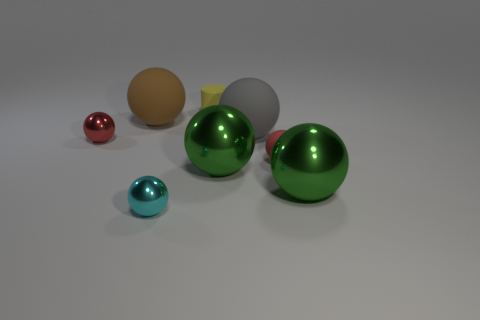Is the number of shiny objects right of the cyan metal object greater than the number of tiny brown metal cylinders?
Give a very brief answer. Yes. There is a big metal ball that is left of the tiny sphere on the right side of the cyan shiny object; what number of rubber objects are on the right side of it?
Keep it short and to the point. 2. Is the shape of the red thing to the right of the big brown ball the same as  the yellow matte thing?
Your answer should be very brief. No. What material is the tiny object that is on the left side of the small cyan ball?
Your answer should be compact. Metal. There is a big object that is in front of the red matte ball and on the left side of the big gray sphere; what is its shape?
Your response must be concise. Sphere. What is the large brown object made of?
Your answer should be very brief. Rubber. How many cylinders are big gray things or green metal things?
Provide a short and direct response. 0. Does the large brown object have the same material as the small cyan thing?
Ensure brevity in your answer.  No. There is a brown object that is the same shape as the tiny red rubber thing; what is its size?
Offer a terse response. Large. There is a big sphere that is left of the gray rubber thing and in front of the large brown thing; what is its material?
Give a very brief answer. Metal. 